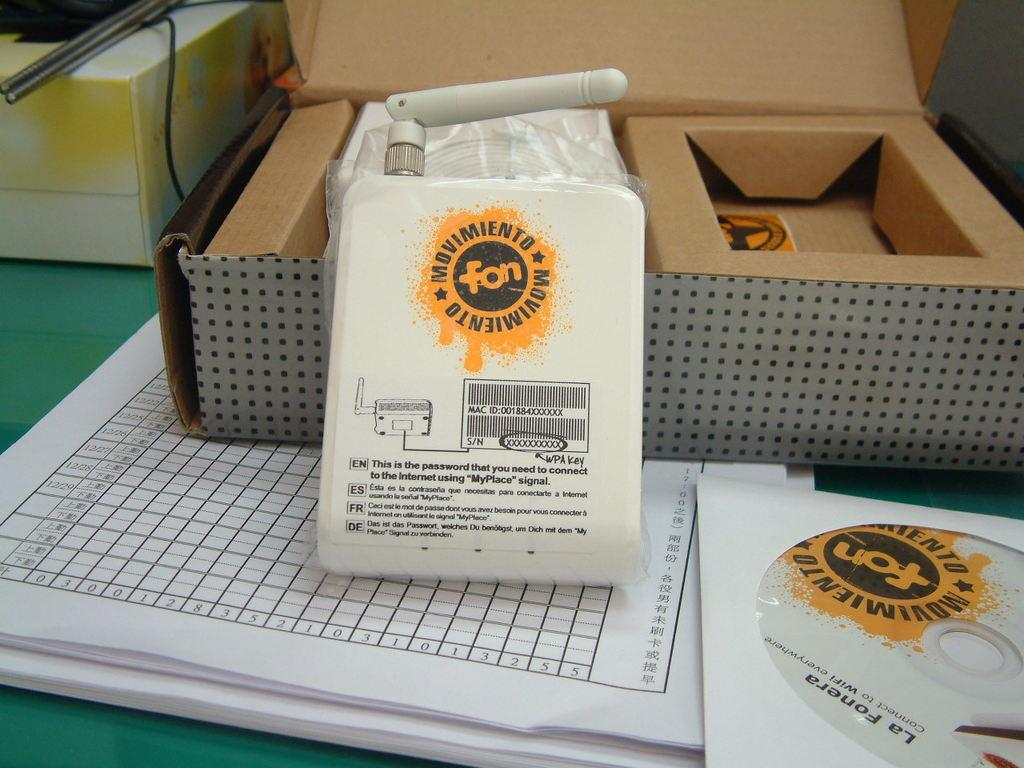<image>
Render a clear and concise summary of the photo. the word fon that is on a piece of paper 